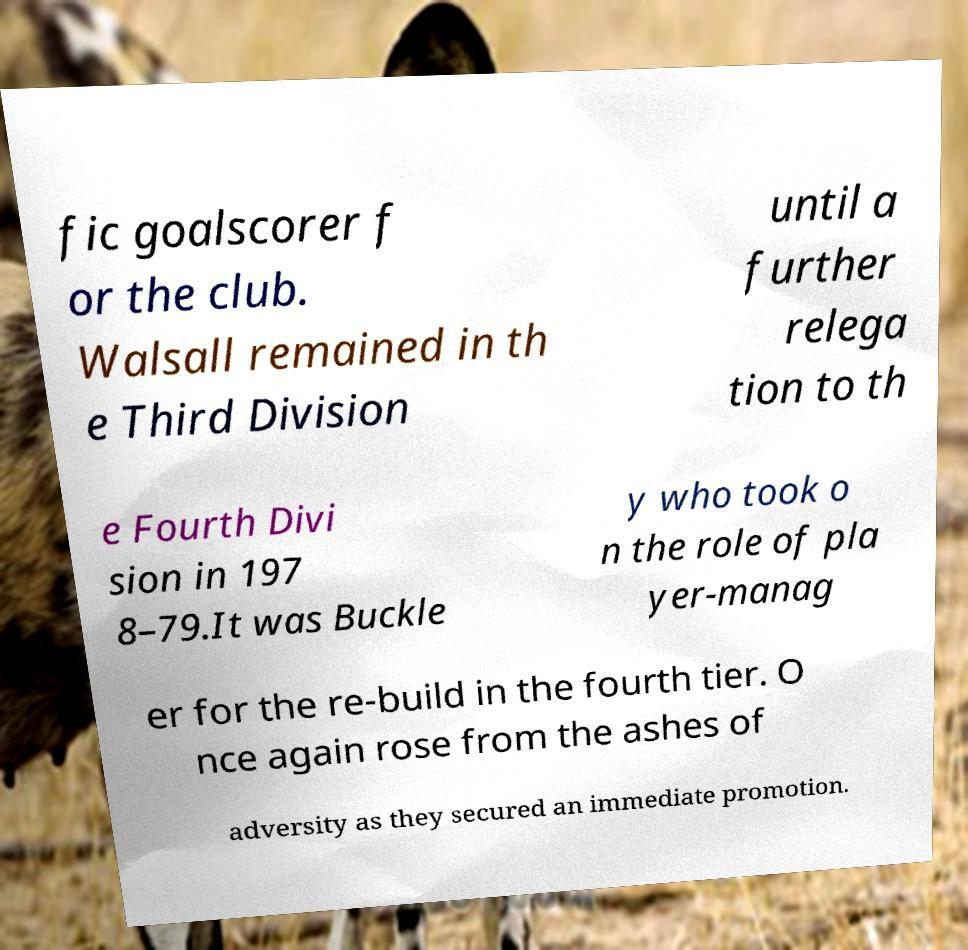What messages or text are displayed in this image? I need them in a readable, typed format. fic goalscorer f or the club. Walsall remained in th e Third Division until a further relega tion to th e Fourth Divi sion in 197 8–79.It was Buckle y who took o n the role of pla yer-manag er for the re-build in the fourth tier. O nce again rose from the ashes of adversity as they secured an immediate promotion. 